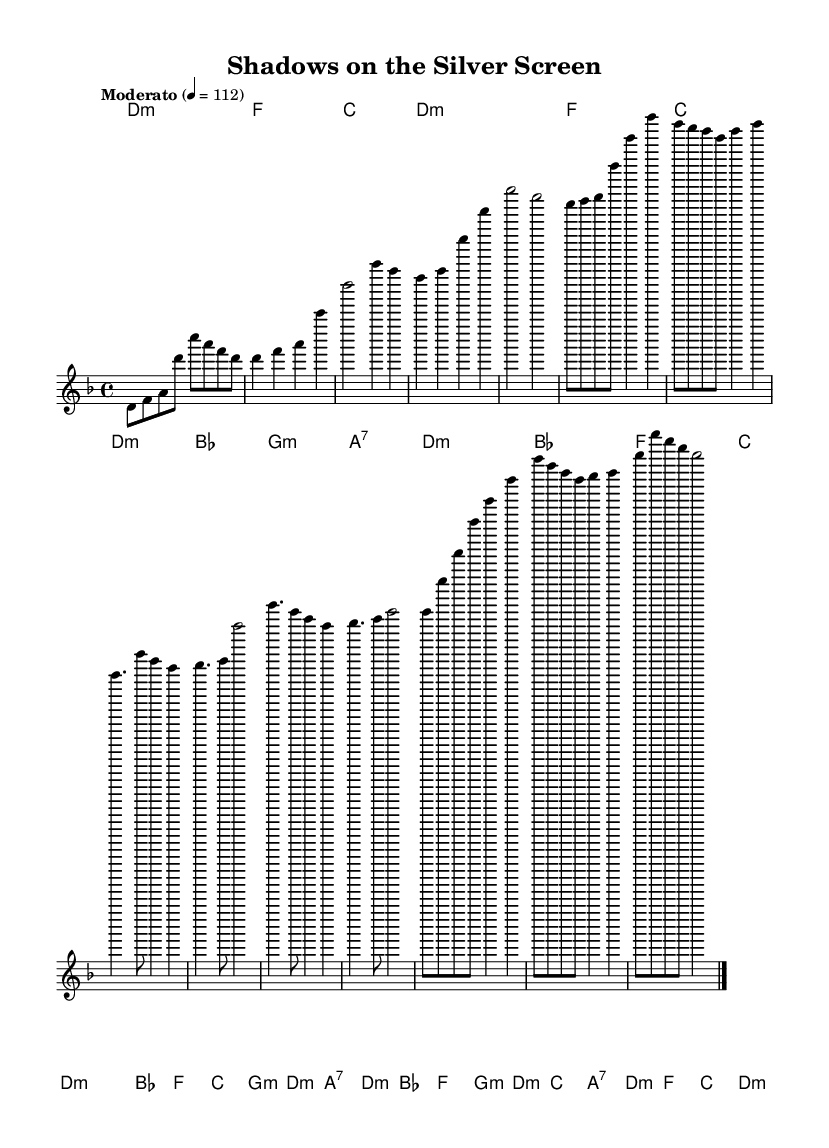What is the key signature of this music? The key signature is D minor, which has one flat (B flat). This can be identified by looking at the key signature indicated at the beginning of the sheet music.
Answer: D minor What is the time signature of this music? The time signature is four-four time, indicated at the beginning of the score. This means there are four beats in each measure and a quarter note gets one beat.
Answer: Four-four What is the tempo marking of the piece? The tempo marking is "Moderato," which suggests a moderate speed. It can be found written above the staff near the beginning of the sheet music.
Answer: Moderato How many measures are in the Chorus section? The Chorus section contains four measures. This can be determined by counting the individual segments of music notated within that section.
Answer: Four measures What is the first chord in the piece? The first chord is D minor, which is indicated in the chord changes at the beginning of the score.
Answer: D minor What is the last note of the melody? The last note of the melody is D. To find this, one can go to the end of the melody line and identify the note value written there.
Answer: D How do the lyrics relate to the overall narrative of the piece? The lyrics paint a vivid scene reminiscent of silent films, engaging listeners with deep imagery and storytelling elements that creates an emotional journey. This thematic aspect can be inferred from the melodic structure and lyrical context often found in K-Pop storytelling.
Answer: Storytelling 